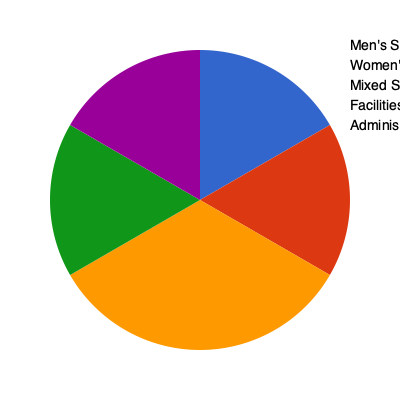Based on the pie chart illustrating the distribution of funding in sports programs, what percentage of the total budget would need to be reallocated from men's sports to women's sports to achieve equal funding between these two categories? To determine the percentage that needs to be reallocated from men's sports to women's sports for equal funding, we need to follow these steps:

1. Identify the current percentages:
   Men's sports: 60%
   Women's sports: 25%

2. Calculate the total percentage for men's and women's sports combined:
   60% + 25% = 85%

3. Determine the equal distribution percentage:
   85% ÷ 2 = 42.5%

4. Calculate the difference between the current men's sports funding and the equal distribution:
   60% - 42.5% = 17.5%

This 17.5% is the amount that needs to be reallocated from men's sports to women's sports to achieve equal funding.

To verify:
- New men's sports funding: 60% - 17.5% = 42.5%
- New women's sports funding: 25% + 17.5% = 42.5%

Both categories would then have equal funding at 42.5% each.
Answer: 17.5% 